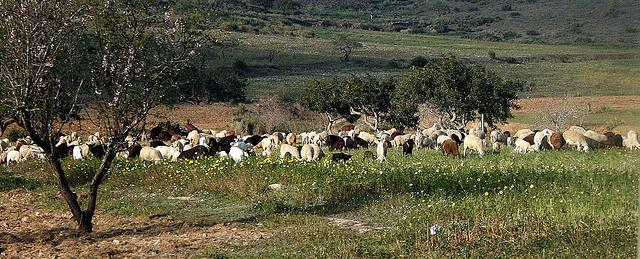What are the animals doing? Please explain your reasoning. resting. The animals are taking a breather. 